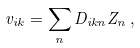Convert formula to latex. <formula><loc_0><loc_0><loc_500><loc_500>v _ { i k } = \sum _ { n } D _ { i k n } Z _ { n } \, ,</formula> 